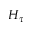Convert formula to latex. <formula><loc_0><loc_0><loc_500><loc_500>H _ { \tau }</formula> 